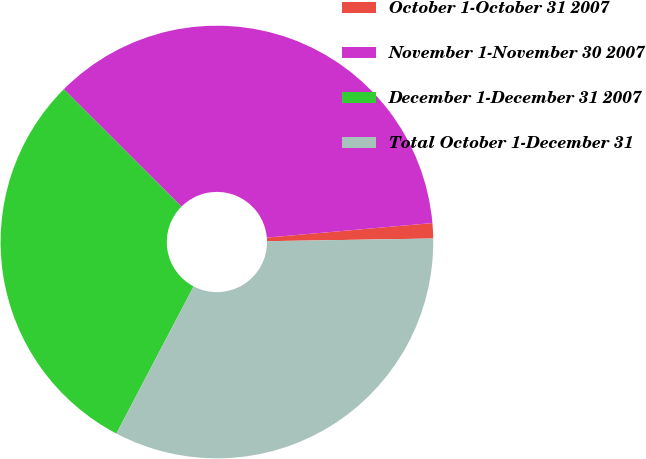Convert chart to OTSL. <chart><loc_0><loc_0><loc_500><loc_500><pie_chart><fcel>October 1-October 31 2007<fcel>November 1-November 30 2007<fcel>December 1-December 31 2007<fcel>Total October 1-December 31<nl><fcel>1.14%<fcel>36.12%<fcel>29.79%<fcel>32.95%<nl></chart> 